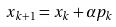Convert formula to latex. <formula><loc_0><loc_0><loc_500><loc_500>x _ { k + 1 } = x _ { k } + \alpha p _ { k }</formula> 